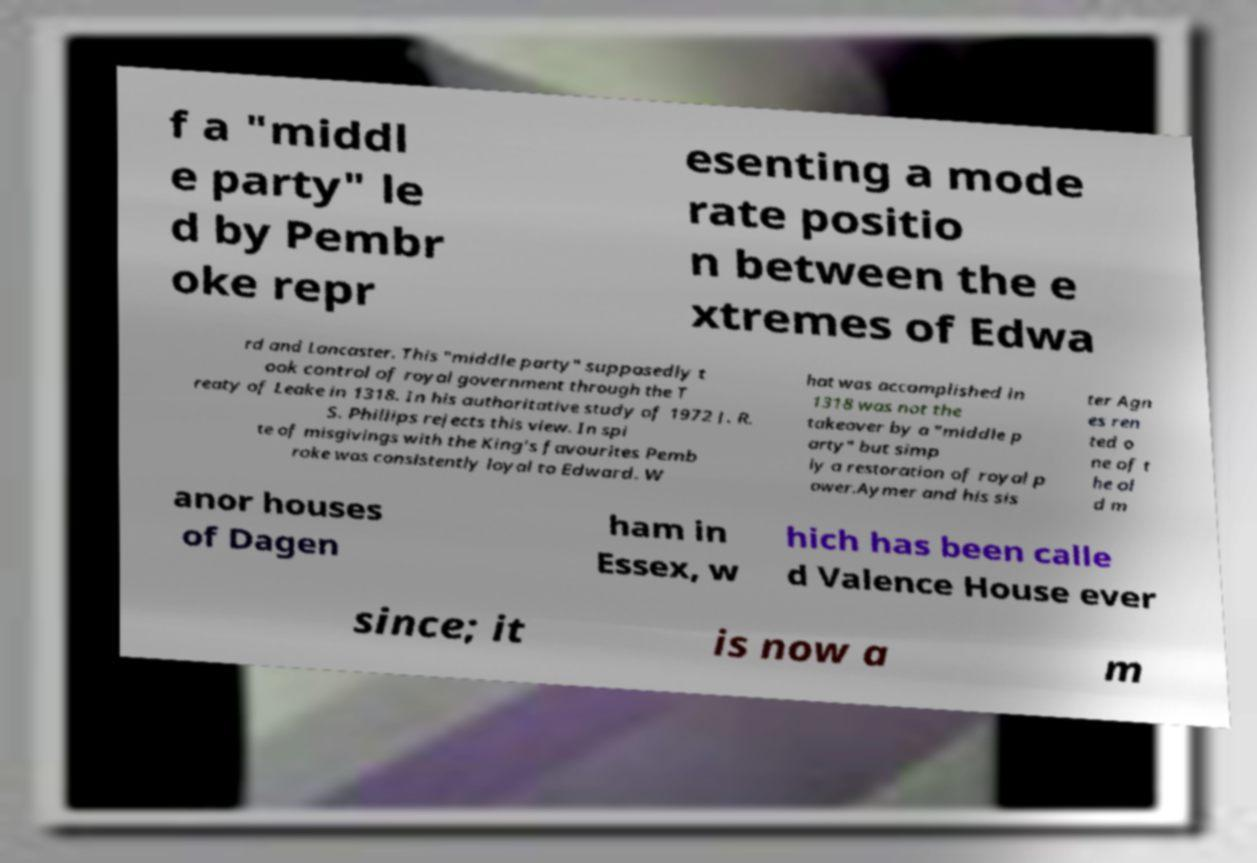For documentation purposes, I need the text within this image transcribed. Could you provide that? f a "middl e party" le d by Pembr oke repr esenting a mode rate positio n between the e xtremes of Edwa rd and Lancaster. This "middle party" supposedly t ook control of royal government through the T reaty of Leake in 1318. In his authoritative study of 1972 J. R. S. Phillips rejects this view. In spi te of misgivings with the King's favourites Pemb roke was consistently loyal to Edward. W hat was accomplished in 1318 was not the takeover by a "middle p arty" but simp ly a restoration of royal p ower.Aymer and his sis ter Agn es ren ted o ne of t he ol d m anor houses of Dagen ham in Essex, w hich has been calle d Valence House ever since; it is now a m 